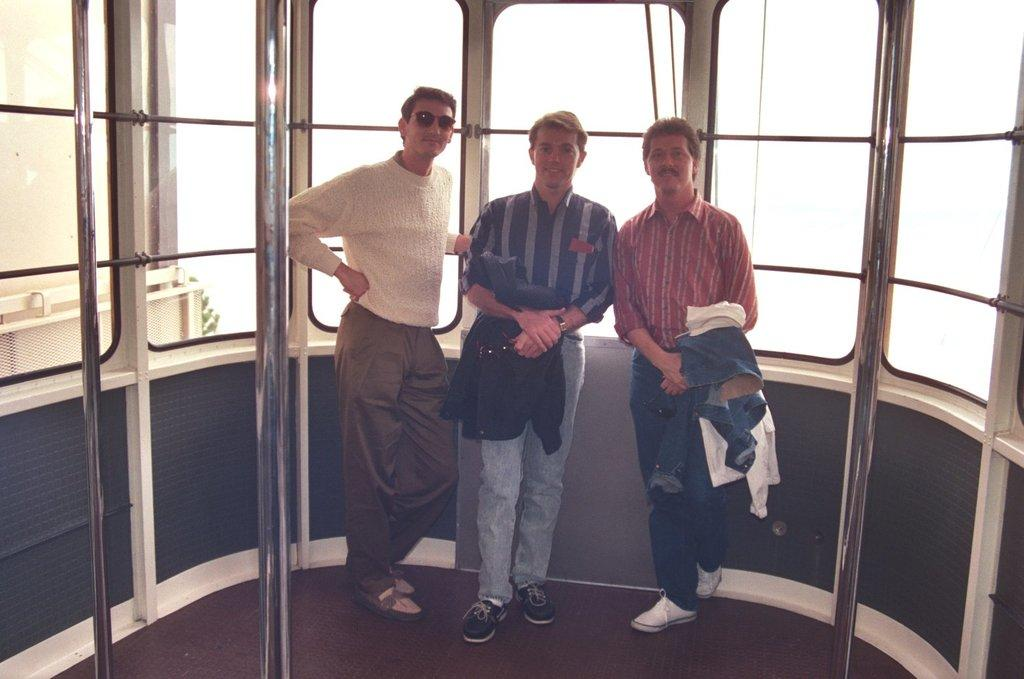How many persons are present in the image? There are three persons standing in the image. What can be seen in the image besides the persons? There are windows, iron rods, a carpet, and a building visible in the image. What type of elbow support can be seen in the image? There is no elbow support present in the image. How many potatoes are visible in the image? There are no potatoes visible in the image. What type of shoes are the persons wearing in the image? The provided facts do not mention the type of shoes the persons are wearing, so it cannot be determined from the image. 